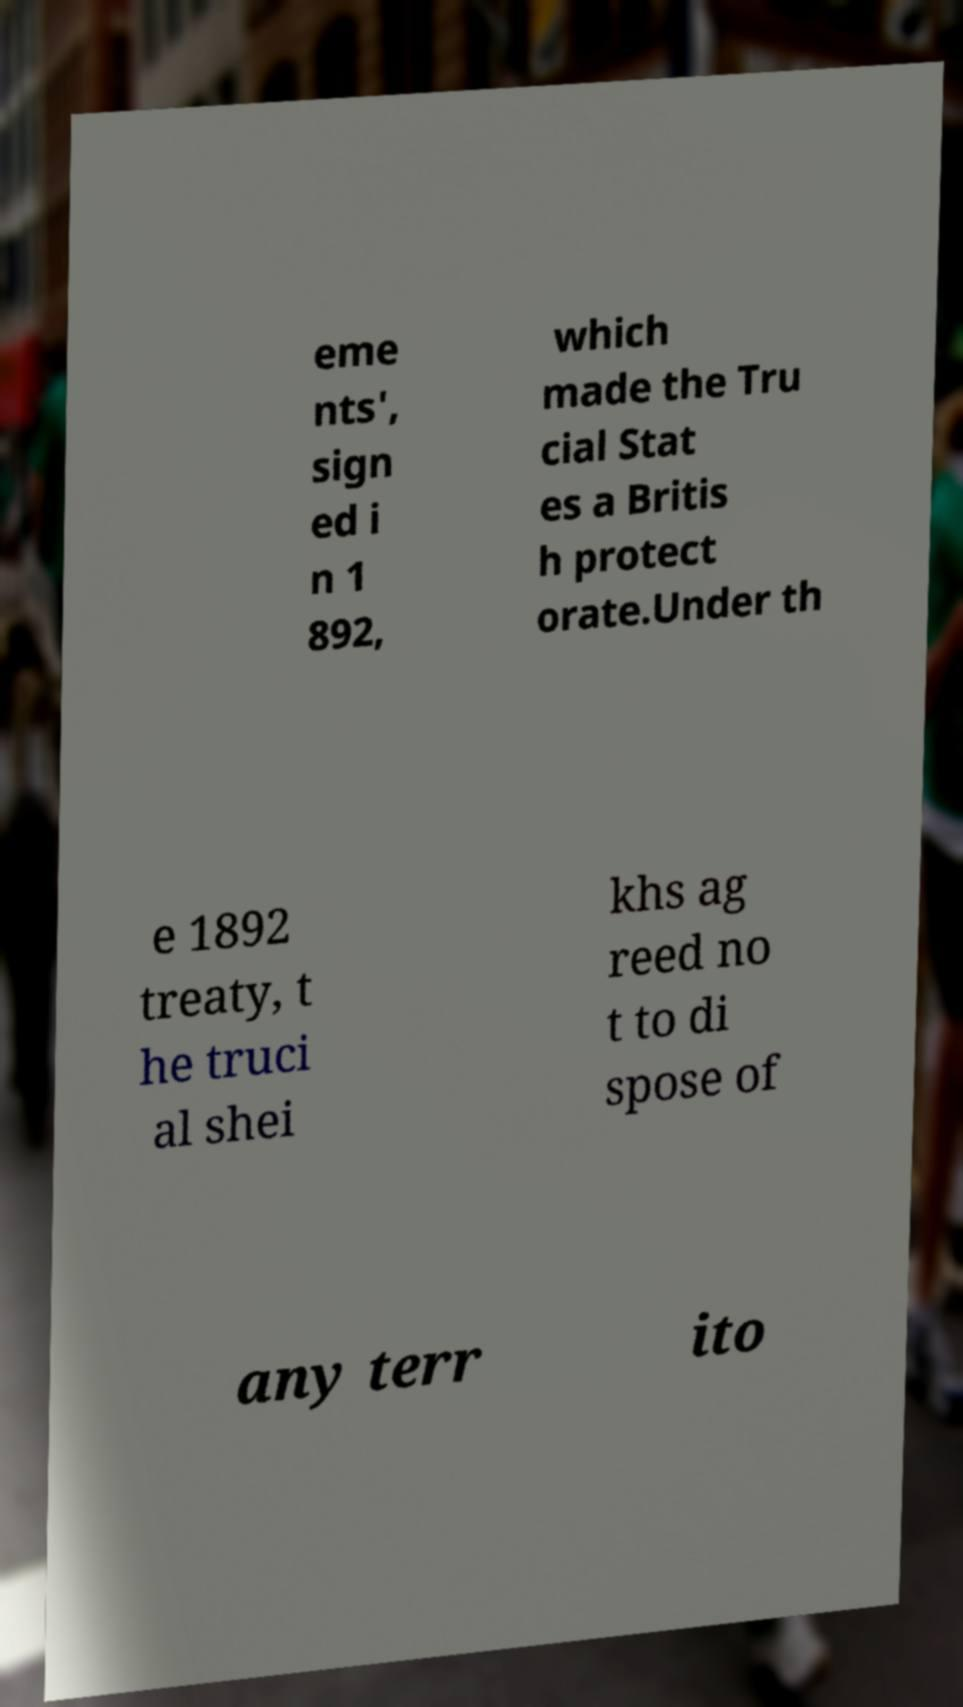For documentation purposes, I need the text within this image transcribed. Could you provide that? eme nts', sign ed i n 1 892, which made the Tru cial Stat es a Britis h protect orate.Under th e 1892 treaty, t he truci al shei khs ag reed no t to di spose of any terr ito 